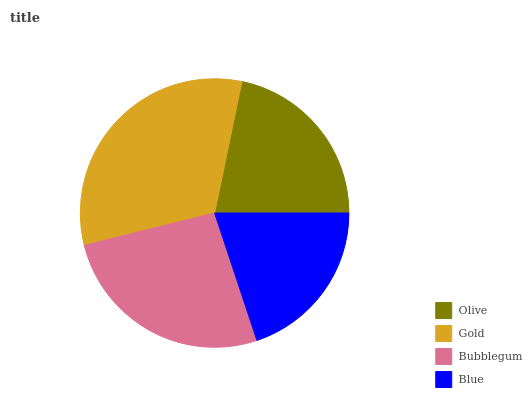Is Blue the minimum?
Answer yes or no. Yes. Is Gold the maximum?
Answer yes or no. Yes. Is Bubblegum the minimum?
Answer yes or no. No. Is Bubblegum the maximum?
Answer yes or no. No. Is Gold greater than Bubblegum?
Answer yes or no. Yes. Is Bubblegum less than Gold?
Answer yes or no. Yes. Is Bubblegum greater than Gold?
Answer yes or no. No. Is Gold less than Bubblegum?
Answer yes or no. No. Is Bubblegum the high median?
Answer yes or no. Yes. Is Olive the low median?
Answer yes or no. Yes. Is Gold the high median?
Answer yes or no. No. Is Bubblegum the low median?
Answer yes or no. No. 